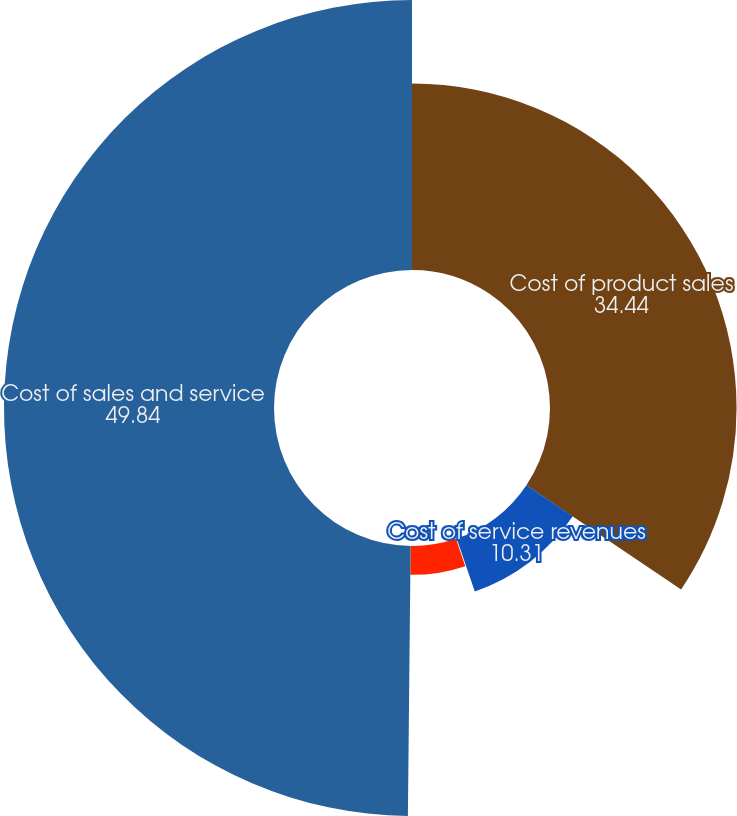Convert chart to OTSL. <chart><loc_0><loc_0><loc_500><loc_500><pie_chart><fcel>Cost of product sales<fcel>Cost of service revenues<fcel>Income (loss) from operating<fcel>General and administrative<fcel>Cost of sales and service<nl><fcel>34.44%<fcel>10.31%<fcel>0.08%<fcel>5.33%<fcel>49.84%<nl></chart> 